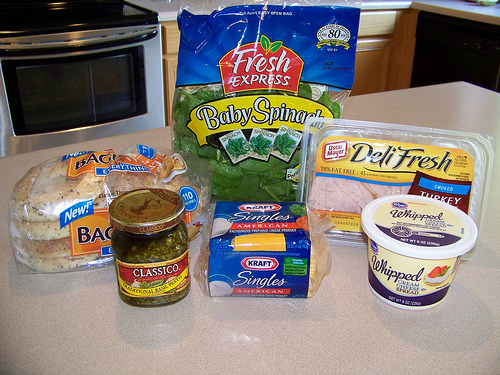<image>
Is there a spinach to the left of the cheese? No. The spinach is not to the left of the cheese. From this viewpoint, they have a different horizontal relationship. Where is the spinach in relation to the buns? Is it in the buns? No. The spinach is not contained within the buns. These objects have a different spatial relationship. 